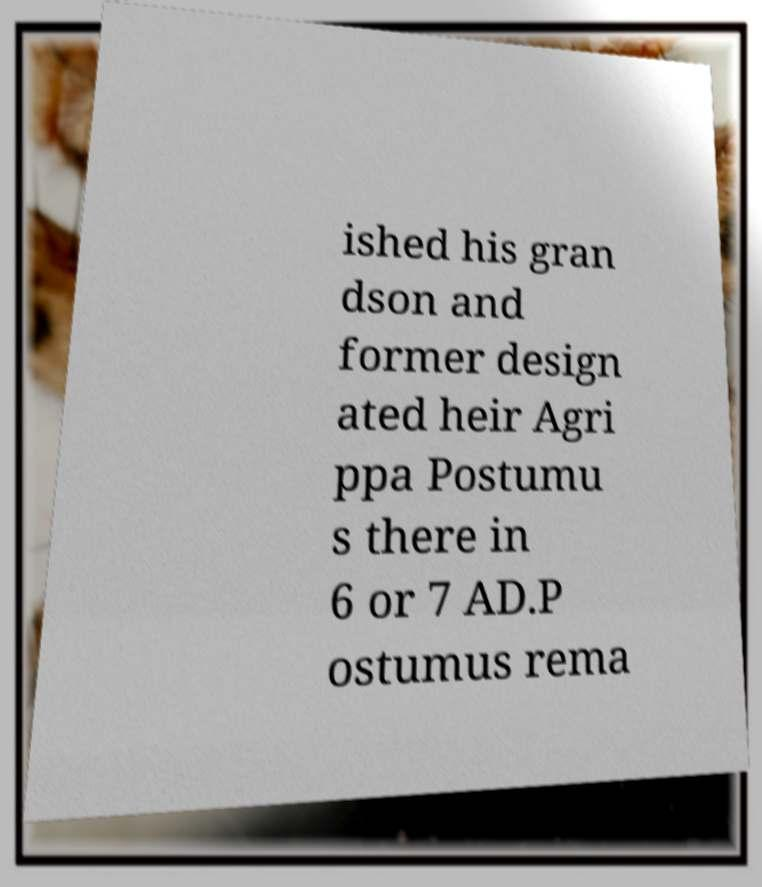Please read and relay the text visible in this image. What does it say? ished his gran dson and former design ated heir Agri ppa Postumu s there in 6 or 7 AD.P ostumus rema 